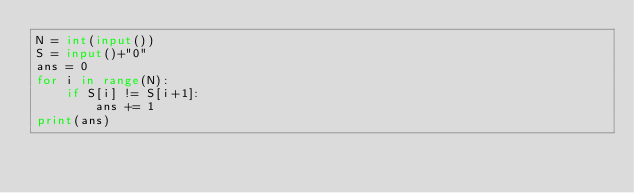<code> <loc_0><loc_0><loc_500><loc_500><_Python_>N = int(input())
S = input()+"0"
ans = 0
for i in range(N):
    if S[i] != S[i+1]:
        ans += 1
print(ans)</code> 